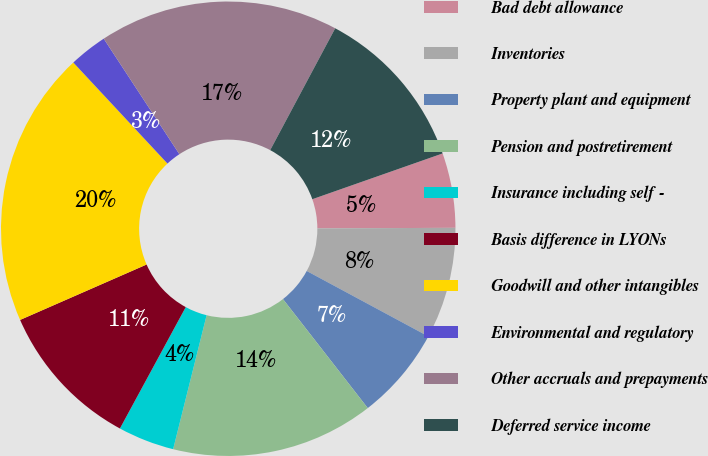Convert chart. <chart><loc_0><loc_0><loc_500><loc_500><pie_chart><fcel>Bad debt allowance<fcel>Inventories<fcel>Property plant and equipment<fcel>Pension and postretirement<fcel>Insurance including self -<fcel>Basis difference in LYONs<fcel>Goodwill and other intangibles<fcel>Environmental and regulatory<fcel>Other accruals and prepayments<fcel>Deferred service income<nl><fcel>5.31%<fcel>7.92%<fcel>6.62%<fcel>14.42%<fcel>4.01%<fcel>10.52%<fcel>19.63%<fcel>2.71%<fcel>17.03%<fcel>11.82%<nl></chart> 